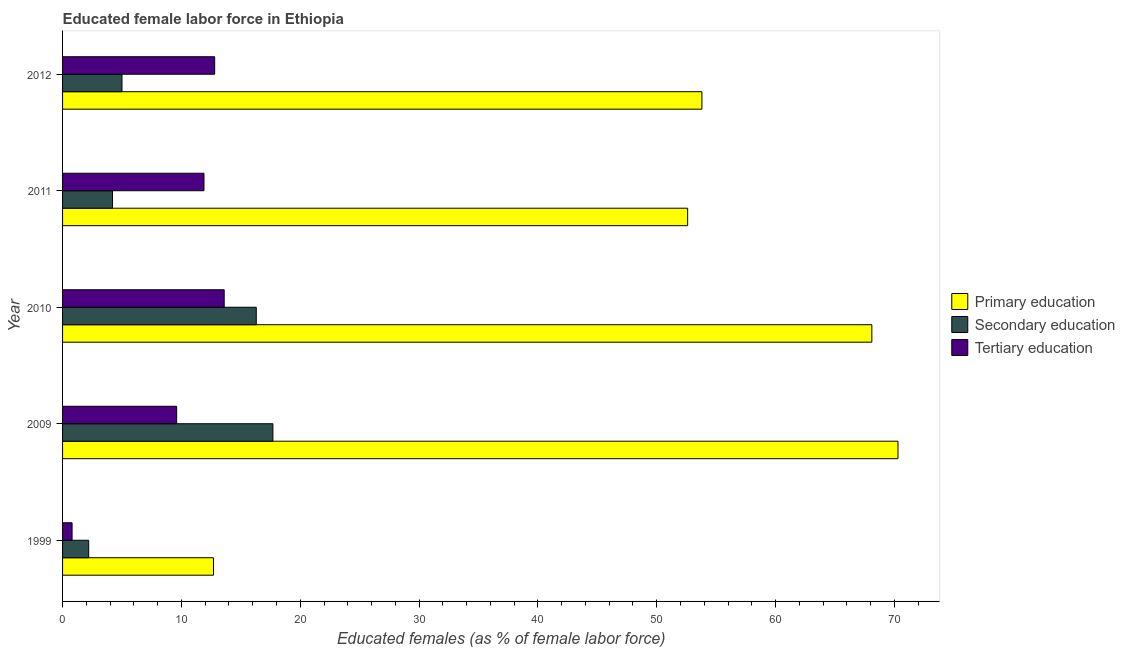How many different coloured bars are there?
Provide a succinct answer. 3. How many groups of bars are there?
Ensure brevity in your answer.  5. How many bars are there on the 2nd tick from the top?
Ensure brevity in your answer.  3. How many bars are there on the 5th tick from the bottom?
Make the answer very short. 3. What is the percentage of female labor force who received secondary education in 2011?
Your answer should be compact. 4.2. Across all years, what is the maximum percentage of female labor force who received tertiary education?
Provide a succinct answer. 13.6. Across all years, what is the minimum percentage of female labor force who received tertiary education?
Your answer should be very brief. 0.8. What is the total percentage of female labor force who received secondary education in the graph?
Your answer should be very brief. 45.4. What is the difference between the percentage of female labor force who received secondary education in 1999 and that in 2009?
Provide a short and direct response. -15.5. What is the difference between the percentage of female labor force who received secondary education in 1999 and the percentage of female labor force who received primary education in 2012?
Provide a short and direct response. -51.6. What is the average percentage of female labor force who received primary education per year?
Your answer should be compact. 51.5. In the year 2012, what is the difference between the percentage of female labor force who received tertiary education and percentage of female labor force who received secondary education?
Offer a very short reply. 7.8. In how many years, is the percentage of female labor force who received primary education greater than 56 %?
Ensure brevity in your answer.  2. What is the ratio of the percentage of female labor force who received tertiary education in 1999 to that in 2011?
Make the answer very short. 0.07. Is the percentage of female labor force who received tertiary education in 2009 less than that in 2011?
Keep it short and to the point. Yes. Is the difference between the percentage of female labor force who received secondary education in 2010 and 2012 greater than the difference between the percentage of female labor force who received primary education in 2010 and 2012?
Your response must be concise. No. In how many years, is the percentage of female labor force who received tertiary education greater than the average percentage of female labor force who received tertiary education taken over all years?
Offer a very short reply. 3. What does the 1st bar from the top in 2012 represents?
Your answer should be very brief. Tertiary education. What does the 3rd bar from the bottom in 1999 represents?
Your answer should be compact. Tertiary education. Is it the case that in every year, the sum of the percentage of female labor force who received primary education and percentage of female labor force who received secondary education is greater than the percentage of female labor force who received tertiary education?
Keep it short and to the point. Yes. How many bars are there?
Your answer should be compact. 15. Are all the bars in the graph horizontal?
Your response must be concise. Yes. What is the difference between two consecutive major ticks on the X-axis?
Your answer should be very brief. 10. Are the values on the major ticks of X-axis written in scientific E-notation?
Make the answer very short. No. Does the graph contain any zero values?
Your response must be concise. No. Does the graph contain grids?
Ensure brevity in your answer.  No. How are the legend labels stacked?
Give a very brief answer. Vertical. What is the title of the graph?
Make the answer very short. Educated female labor force in Ethiopia. What is the label or title of the X-axis?
Your response must be concise. Educated females (as % of female labor force). What is the Educated females (as % of female labor force) of Primary education in 1999?
Provide a succinct answer. 12.7. What is the Educated females (as % of female labor force) of Secondary education in 1999?
Ensure brevity in your answer.  2.2. What is the Educated females (as % of female labor force) of Tertiary education in 1999?
Offer a very short reply. 0.8. What is the Educated females (as % of female labor force) of Primary education in 2009?
Offer a terse response. 70.3. What is the Educated females (as % of female labor force) of Secondary education in 2009?
Give a very brief answer. 17.7. What is the Educated females (as % of female labor force) of Tertiary education in 2009?
Offer a very short reply. 9.6. What is the Educated females (as % of female labor force) of Primary education in 2010?
Your response must be concise. 68.1. What is the Educated females (as % of female labor force) in Secondary education in 2010?
Provide a short and direct response. 16.3. What is the Educated females (as % of female labor force) in Tertiary education in 2010?
Make the answer very short. 13.6. What is the Educated females (as % of female labor force) of Primary education in 2011?
Offer a very short reply. 52.6. What is the Educated females (as % of female labor force) of Secondary education in 2011?
Provide a short and direct response. 4.2. What is the Educated females (as % of female labor force) in Tertiary education in 2011?
Give a very brief answer. 11.9. What is the Educated females (as % of female labor force) in Primary education in 2012?
Give a very brief answer. 53.8. What is the Educated females (as % of female labor force) in Secondary education in 2012?
Your answer should be very brief. 5. What is the Educated females (as % of female labor force) of Tertiary education in 2012?
Your answer should be compact. 12.8. Across all years, what is the maximum Educated females (as % of female labor force) of Primary education?
Your answer should be compact. 70.3. Across all years, what is the maximum Educated females (as % of female labor force) in Secondary education?
Provide a short and direct response. 17.7. Across all years, what is the maximum Educated females (as % of female labor force) of Tertiary education?
Your response must be concise. 13.6. Across all years, what is the minimum Educated females (as % of female labor force) in Primary education?
Provide a succinct answer. 12.7. Across all years, what is the minimum Educated females (as % of female labor force) in Secondary education?
Make the answer very short. 2.2. Across all years, what is the minimum Educated females (as % of female labor force) in Tertiary education?
Your answer should be very brief. 0.8. What is the total Educated females (as % of female labor force) of Primary education in the graph?
Provide a short and direct response. 257.5. What is the total Educated females (as % of female labor force) of Secondary education in the graph?
Ensure brevity in your answer.  45.4. What is the total Educated females (as % of female labor force) in Tertiary education in the graph?
Your answer should be very brief. 48.7. What is the difference between the Educated females (as % of female labor force) of Primary education in 1999 and that in 2009?
Offer a very short reply. -57.6. What is the difference between the Educated females (as % of female labor force) in Secondary education in 1999 and that in 2009?
Your answer should be very brief. -15.5. What is the difference between the Educated females (as % of female labor force) of Tertiary education in 1999 and that in 2009?
Provide a short and direct response. -8.8. What is the difference between the Educated females (as % of female labor force) of Primary education in 1999 and that in 2010?
Your response must be concise. -55.4. What is the difference between the Educated females (as % of female labor force) of Secondary education in 1999 and that in 2010?
Offer a terse response. -14.1. What is the difference between the Educated females (as % of female labor force) of Tertiary education in 1999 and that in 2010?
Your answer should be compact. -12.8. What is the difference between the Educated females (as % of female labor force) of Primary education in 1999 and that in 2011?
Your response must be concise. -39.9. What is the difference between the Educated females (as % of female labor force) in Secondary education in 1999 and that in 2011?
Offer a very short reply. -2. What is the difference between the Educated females (as % of female labor force) in Tertiary education in 1999 and that in 2011?
Offer a very short reply. -11.1. What is the difference between the Educated females (as % of female labor force) of Primary education in 1999 and that in 2012?
Your answer should be very brief. -41.1. What is the difference between the Educated females (as % of female labor force) in Secondary education in 2009 and that in 2010?
Provide a short and direct response. 1.4. What is the difference between the Educated females (as % of female labor force) of Tertiary education in 2009 and that in 2010?
Provide a succinct answer. -4. What is the difference between the Educated females (as % of female labor force) in Primary education in 2009 and that in 2011?
Keep it short and to the point. 17.7. What is the difference between the Educated females (as % of female labor force) in Tertiary education in 2009 and that in 2011?
Provide a short and direct response. -2.3. What is the difference between the Educated females (as % of female labor force) of Secondary education in 2009 and that in 2012?
Give a very brief answer. 12.7. What is the difference between the Educated females (as % of female labor force) of Tertiary education in 2009 and that in 2012?
Keep it short and to the point. -3.2. What is the difference between the Educated females (as % of female labor force) in Tertiary education in 2010 and that in 2011?
Make the answer very short. 1.7. What is the difference between the Educated females (as % of female labor force) in Secondary education in 2010 and that in 2012?
Ensure brevity in your answer.  11.3. What is the difference between the Educated females (as % of female labor force) of Tertiary education in 2010 and that in 2012?
Your answer should be compact. 0.8. What is the difference between the Educated females (as % of female labor force) of Primary education in 2011 and that in 2012?
Keep it short and to the point. -1.2. What is the difference between the Educated females (as % of female labor force) in Secondary education in 2011 and that in 2012?
Make the answer very short. -0.8. What is the difference between the Educated females (as % of female labor force) in Tertiary education in 2011 and that in 2012?
Your response must be concise. -0.9. What is the difference between the Educated females (as % of female labor force) in Primary education in 1999 and the Educated females (as % of female labor force) in Secondary education in 2010?
Provide a short and direct response. -3.6. What is the difference between the Educated females (as % of female labor force) of Secondary education in 1999 and the Educated females (as % of female labor force) of Tertiary education in 2010?
Your answer should be compact. -11.4. What is the difference between the Educated females (as % of female labor force) in Primary education in 1999 and the Educated females (as % of female labor force) in Secondary education in 2011?
Your answer should be compact. 8.5. What is the difference between the Educated females (as % of female labor force) in Secondary education in 1999 and the Educated females (as % of female labor force) in Tertiary education in 2011?
Offer a terse response. -9.7. What is the difference between the Educated females (as % of female labor force) of Primary education in 1999 and the Educated females (as % of female labor force) of Tertiary education in 2012?
Ensure brevity in your answer.  -0.1. What is the difference between the Educated females (as % of female labor force) of Secondary education in 1999 and the Educated females (as % of female labor force) of Tertiary education in 2012?
Your answer should be very brief. -10.6. What is the difference between the Educated females (as % of female labor force) in Primary education in 2009 and the Educated females (as % of female labor force) in Secondary education in 2010?
Offer a terse response. 54. What is the difference between the Educated females (as % of female labor force) of Primary education in 2009 and the Educated females (as % of female labor force) of Tertiary education in 2010?
Offer a very short reply. 56.7. What is the difference between the Educated females (as % of female labor force) in Primary education in 2009 and the Educated females (as % of female labor force) in Secondary education in 2011?
Make the answer very short. 66.1. What is the difference between the Educated females (as % of female labor force) in Primary education in 2009 and the Educated females (as % of female labor force) in Tertiary education in 2011?
Give a very brief answer. 58.4. What is the difference between the Educated females (as % of female labor force) in Secondary education in 2009 and the Educated females (as % of female labor force) in Tertiary education in 2011?
Offer a very short reply. 5.8. What is the difference between the Educated females (as % of female labor force) of Primary education in 2009 and the Educated females (as % of female labor force) of Secondary education in 2012?
Your answer should be compact. 65.3. What is the difference between the Educated females (as % of female labor force) in Primary education in 2009 and the Educated females (as % of female labor force) in Tertiary education in 2012?
Provide a short and direct response. 57.5. What is the difference between the Educated females (as % of female labor force) in Secondary education in 2009 and the Educated females (as % of female labor force) in Tertiary education in 2012?
Ensure brevity in your answer.  4.9. What is the difference between the Educated females (as % of female labor force) in Primary education in 2010 and the Educated females (as % of female labor force) in Secondary education in 2011?
Your response must be concise. 63.9. What is the difference between the Educated females (as % of female labor force) in Primary education in 2010 and the Educated females (as % of female labor force) in Tertiary education in 2011?
Ensure brevity in your answer.  56.2. What is the difference between the Educated females (as % of female labor force) in Secondary education in 2010 and the Educated females (as % of female labor force) in Tertiary education in 2011?
Provide a short and direct response. 4.4. What is the difference between the Educated females (as % of female labor force) in Primary education in 2010 and the Educated females (as % of female labor force) in Secondary education in 2012?
Make the answer very short. 63.1. What is the difference between the Educated females (as % of female labor force) in Primary education in 2010 and the Educated females (as % of female labor force) in Tertiary education in 2012?
Your answer should be very brief. 55.3. What is the difference between the Educated females (as % of female labor force) in Secondary education in 2010 and the Educated females (as % of female labor force) in Tertiary education in 2012?
Keep it short and to the point. 3.5. What is the difference between the Educated females (as % of female labor force) in Primary education in 2011 and the Educated females (as % of female labor force) in Secondary education in 2012?
Your answer should be very brief. 47.6. What is the difference between the Educated females (as % of female labor force) of Primary education in 2011 and the Educated females (as % of female labor force) of Tertiary education in 2012?
Ensure brevity in your answer.  39.8. What is the average Educated females (as % of female labor force) in Primary education per year?
Offer a terse response. 51.5. What is the average Educated females (as % of female labor force) in Secondary education per year?
Provide a short and direct response. 9.08. What is the average Educated females (as % of female labor force) in Tertiary education per year?
Offer a very short reply. 9.74. In the year 1999, what is the difference between the Educated females (as % of female labor force) in Primary education and Educated females (as % of female labor force) in Secondary education?
Give a very brief answer. 10.5. In the year 1999, what is the difference between the Educated females (as % of female labor force) of Primary education and Educated females (as % of female labor force) of Tertiary education?
Offer a very short reply. 11.9. In the year 1999, what is the difference between the Educated females (as % of female labor force) in Secondary education and Educated females (as % of female labor force) in Tertiary education?
Offer a very short reply. 1.4. In the year 2009, what is the difference between the Educated females (as % of female labor force) in Primary education and Educated females (as % of female labor force) in Secondary education?
Give a very brief answer. 52.6. In the year 2009, what is the difference between the Educated females (as % of female labor force) of Primary education and Educated females (as % of female labor force) of Tertiary education?
Give a very brief answer. 60.7. In the year 2010, what is the difference between the Educated females (as % of female labor force) in Primary education and Educated females (as % of female labor force) in Secondary education?
Offer a very short reply. 51.8. In the year 2010, what is the difference between the Educated females (as % of female labor force) of Primary education and Educated females (as % of female labor force) of Tertiary education?
Keep it short and to the point. 54.5. In the year 2010, what is the difference between the Educated females (as % of female labor force) of Secondary education and Educated females (as % of female labor force) of Tertiary education?
Make the answer very short. 2.7. In the year 2011, what is the difference between the Educated females (as % of female labor force) in Primary education and Educated females (as % of female labor force) in Secondary education?
Ensure brevity in your answer.  48.4. In the year 2011, what is the difference between the Educated females (as % of female labor force) in Primary education and Educated females (as % of female labor force) in Tertiary education?
Provide a short and direct response. 40.7. In the year 2011, what is the difference between the Educated females (as % of female labor force) of Secondary education and Educated females (as % of female labor force) of Tertiary education?
Provide a succinct answer. -7.7. In the year 2012, what is the difference between the Educated females (as % of female labor force) of Primary education and Educated females (as % of female labor force) of Secondary education?
Provide a succinct answer. 48.8. In the year 2012, what is the difference between the Educated females (as % of female labor force) in Secondary education and Educated females (as % of female labor force) in Tertiary education?
Keep it short and to the point. -7.8. What is the ratio of the Educated females (as % of female labor force) of Primary education in 1999 to that in 2009?
Your answer should be very brief. 0.18. What is the ratio of the Educated females (as % of female labor force) of Secondary education in 1999 to that in 2009?
Offer a very short reply. 0.12. What is the ratio of the Educated females (as % of female labor force) in Tertiary education in 1999 to that in 2009?
Give a very brief answer. 0.08. What is the ratio of the Educated females (as % of female labor force) in Primary education in 1999 to that in 2010?
Provide a short and direct response. 0.19. What is the ratio of the Educated females (as % of female labor force) in Secondary education in 1999 to that in 2010?
Your response must be concise. 0.14. What is the ratio of the Educated females (as % of female labor force) of Tertiary education in 1999 to that in 2010?
Offer a terse response. 0.06. What is the ratio of the Educated females (as % of female labor force) of Primary education in 1999 to that in 2011?
Offer a very short reply. 0.24. What is the ratio of the Educated females (as % of female labor force) in Secondary education in 1999 to that in 2011?
Your answer should be very brief. 0.52. What is the ratio of the Educated females (as % of female labor force) in Tertiary education in 1999 to that in 2011?
Your answer should be very brief. 0.07. What is the ratio of the Educated females (as % of female labor force) of Primary education in 1999 to that in 2012?
Your answer should be compact. 0.24. What is the ratio of the Educated females (as % of female labor force) of Secondary education in 1999 to that in 2012?
Your answer should be compact. 0.44. What is the ratio of the Educated females (as % of female labor force) of Tertiary education in 1999 to that in 2012?
Your answer should be very brief. 0.06. What is the ratio of the Educated females (as % of female labor force) of Primary education in 2009 to that in 2010?
Give a very brief answer. 1.03. What is the ratio of the Educated females (as % of female labor force) in Secondary education in 2009 to that in 2010?
Your response must be concise. 1.09. What is the ratio of the Educated females (as % of female labor force) of Tertiary education in 2009 to that in 2010?
Offer a terse response. 0.71. What is the ratio of the Educated females (as % of female labor force) in Primary education in 2009 to that in 2011?
Offer a terse response. 1.34. What is the ratio of the Educated females (as % of female labor force) of Secondary education in 2009 to that in 2011?
Provide a short and direct response. 4.21. What is the ratio of the Educated females (as % of female labor force) in Tertiary education in 2009 to that in 2011?
Your answer should be very brief. 0.81. What is the ratio of the Educated females (as % of female labor force) in Primary education in 2009 to that in 2012?
Your response must be concise. 1.31. What is the ratio of the Educated females (as % of female labor force) of Secondary education in 2009 to that in 2012?
Your response must be concise. 3.54. What is the ratio of the Educated females (as % of female labor force) in Primary education in 2010 to that in 2011?
Offer a very short reply. 1.29. What is the ratio of the Educated females (as % of female labor force) in Secondary education in 2010 to that in 2011?
Offer a terse response. 3.88. What is the ratio of the Educated females (as % of female labor force) in Primary education in 2010 to that in 2012?
Your response must be concise. 1.27. What is the ratio of the Educated females (as % of female labor force) of Secondary education in 2010 to that in 2012?
Ensure brevity in your answer.  3.26. What is the ratio of the Educated females (as % of female labor force) in Primary education in 2011 to that in 2012?
Make the answer very short. 0.98. What is the ratio of the Educated females (as % of female labor force) of Secondary education in 2011 to that in 2012?
Your response must be concise. 0.84. What is the ratio of the Educated females (as % of female labor force) in Tertiary education in 2011 to that in 2012?
Ensure brevity in your answer.  0.93. What is the difference between the highest and the lowest Educated females (as % of female labor force) in Primary education?
Your answer should be very brief. 57.6. 